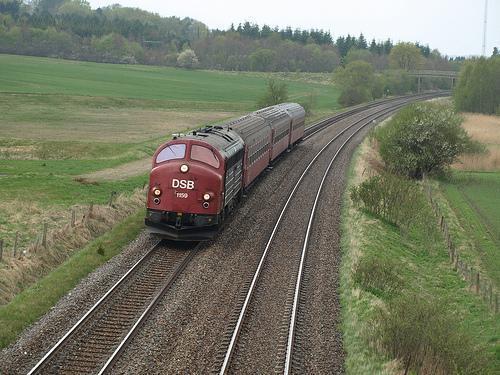How many sets of train tracks are there?
Give a very brief answer. 2. How many cars does the train have?
Give a very brief answer. 3. How many tracks are there?
Give a very brief answer. 2. 